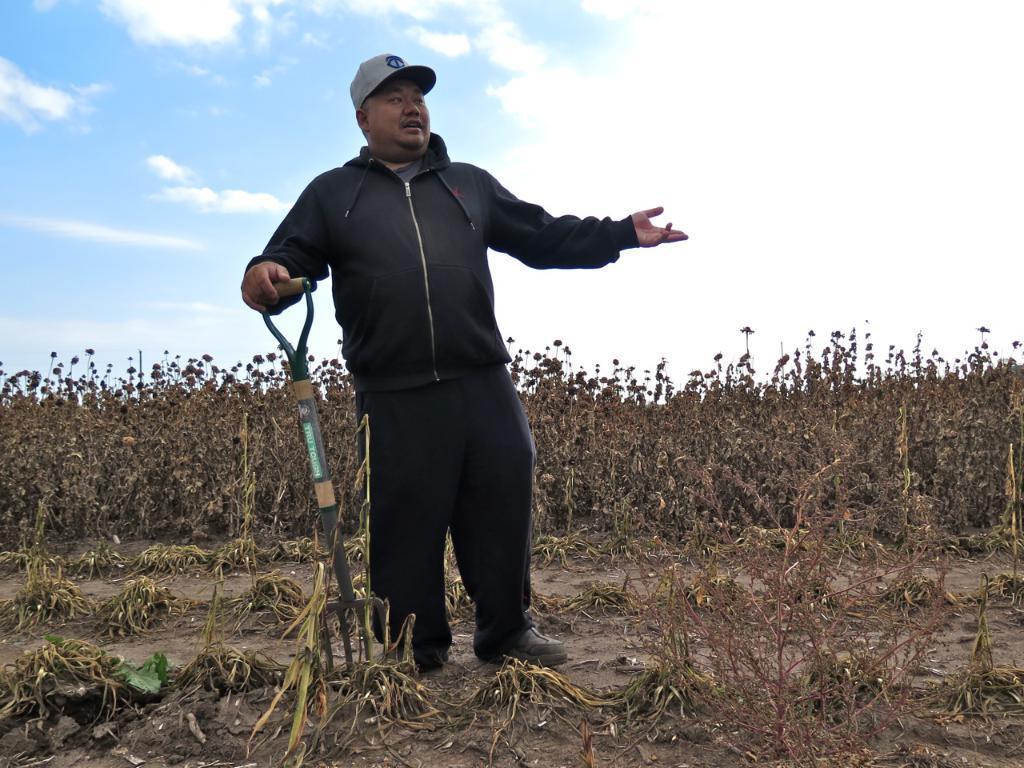Can you describe this image briefly? In this picture, we can see a person carrying an object and we can see the ground with plants and the sky with clouds. 